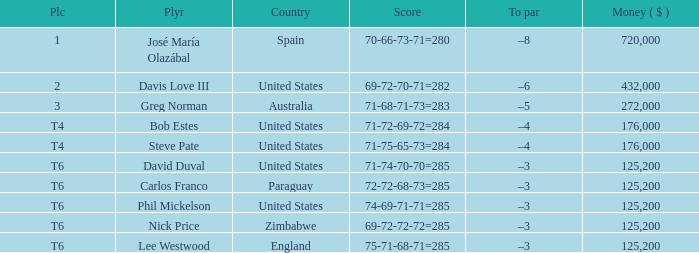Which average money has a Score of 69-72-72-72=285? 125200.0. 